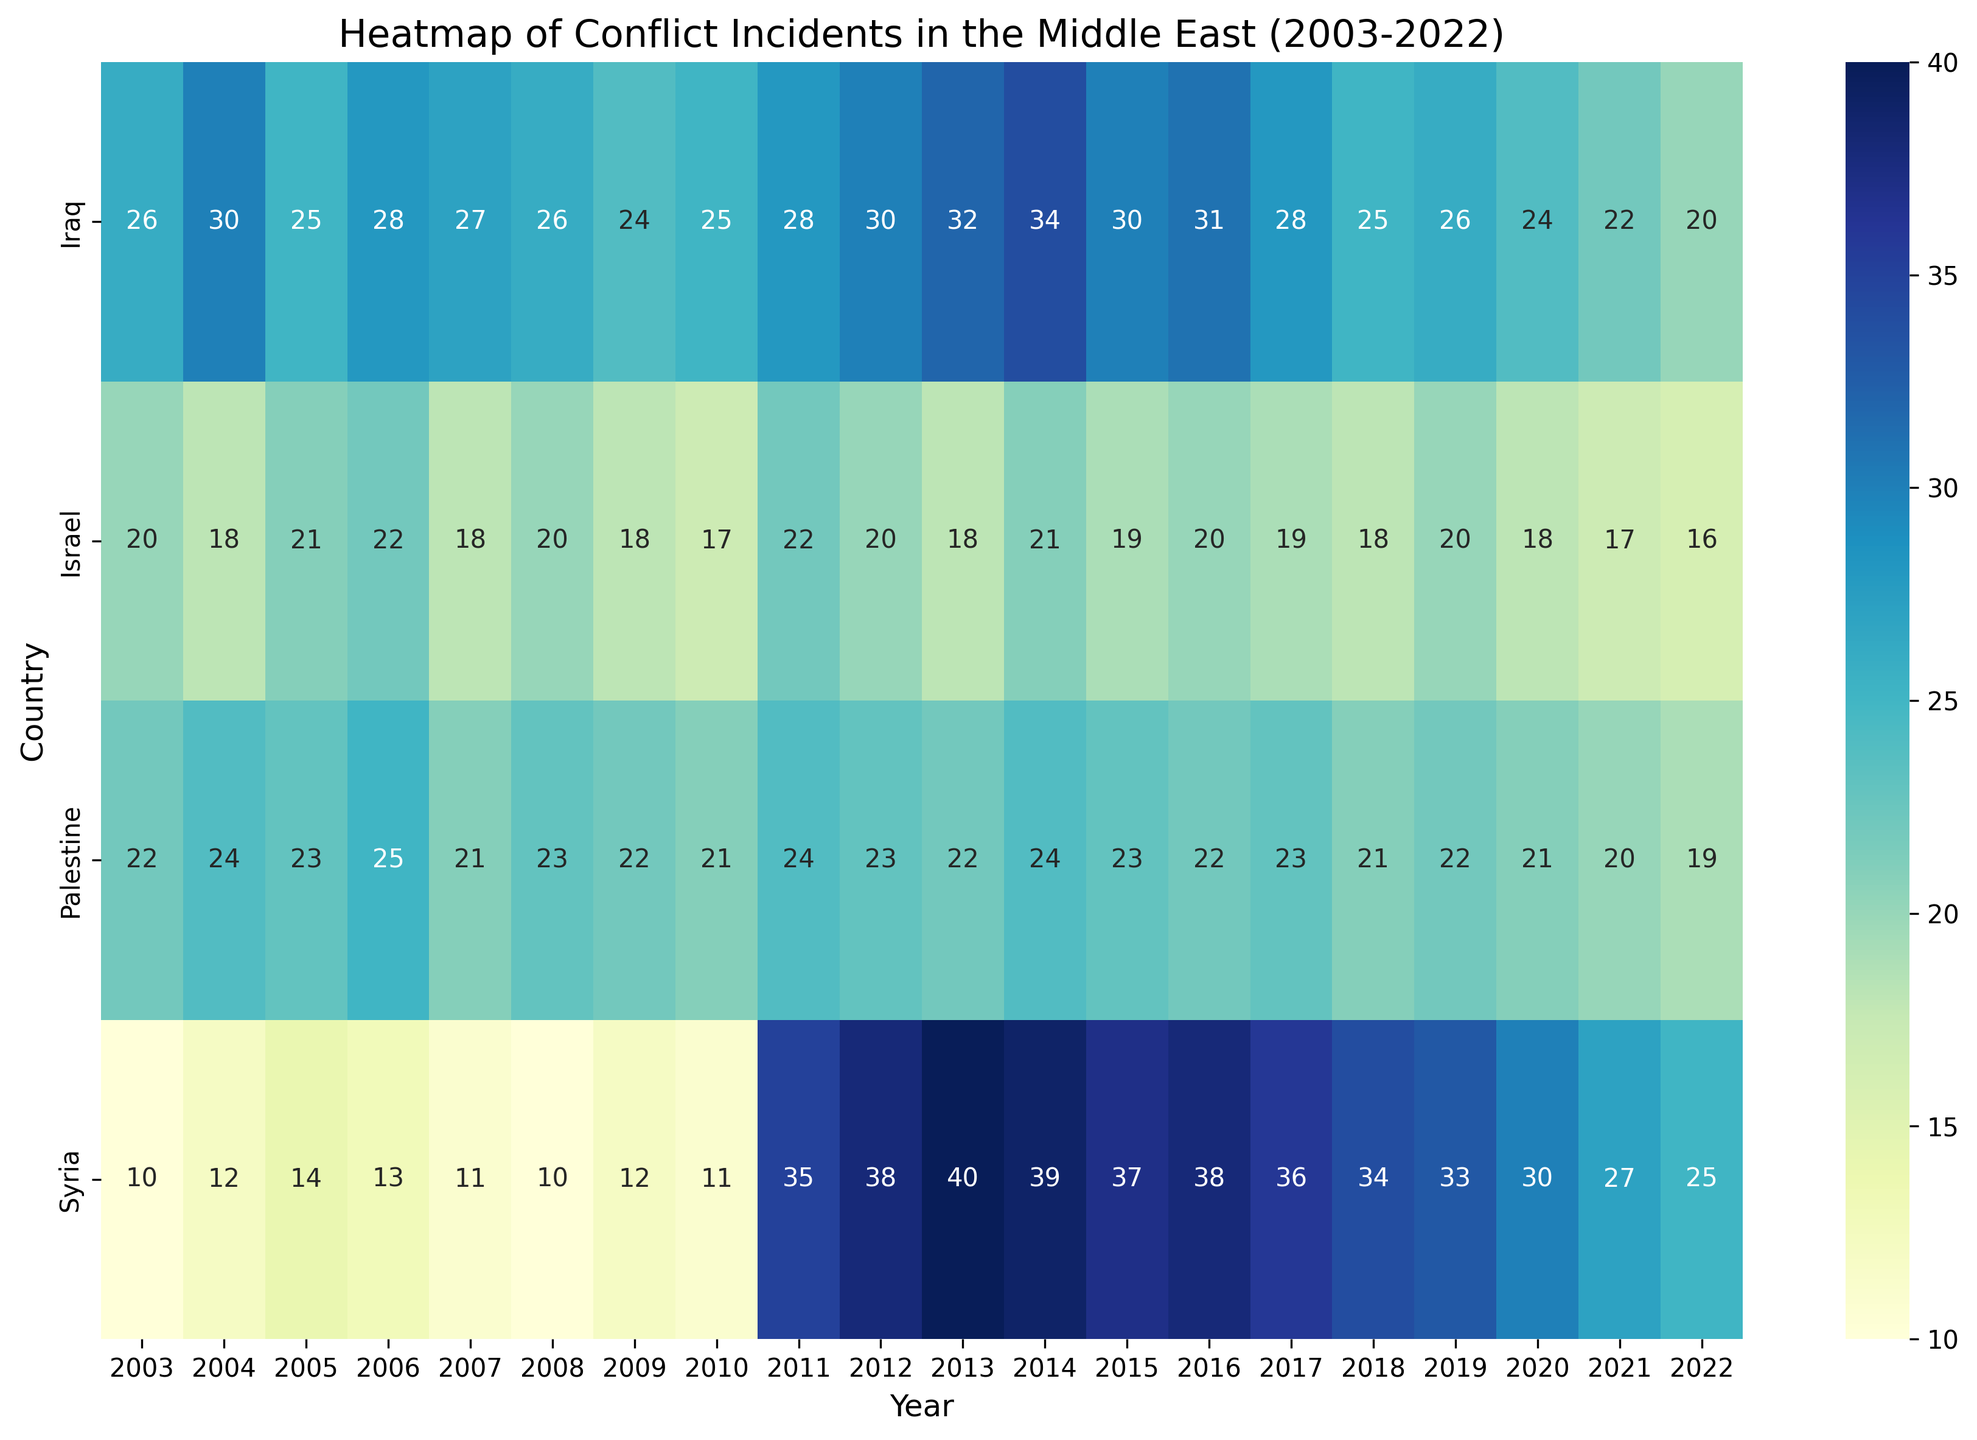Which country had the highest number of conflict incidents in 2011? Looking at the heatmap, the country with the darkest shade in 2011 represents the highest number of conflict incidents. Syria has the darkest shade for this year.
Answer: Syria Which country showed a significant increase in peace initiatives from 2018 to 2022? To determine this, compare the color shades corresponding to peace initiatives between 2018 and 2022 across all countries. Syria shows a significant change in color, indicating an increase in peace initiatives.
Answer: Syria Did Israel have more conflict incidents in 2006 or in 2013? By comparing the color intensity for Israel in both years, we see that the shade for 2006 is darker than for 2013, indicating more conflict incidents in 2006.
Answer: 2006 Which year had the highest number of conflict incidents for Iraq? Identify the darkest shade across the years for Iraq. The darkest shade appears in 2004.
Answer: 2004 Did conflict incidents in Syria generally increase or decrease over the years from 2003 to 2022? Observing the color gradient for Syria from 2003 to 2022, it shows a trend from lighter to darker shades, indicating an increase in conflict incidents over the years.
Answer: Increase How does the average number of conflict incidents in Palestine from 2003 to 2007 compare to that from 2018 to 2022? Calculate the average for each period: (22+24+23+25+21) / 5 = 23 for 2003-2007, and (21+22+23+21+19) / 5 = 21.2 for 2018-2022. The average was higher from 2003 to 2007.
Answer: Higher in 2003-2007 Which year had the fewest conflict incidents in Israel? Find the year with the lightest shade for Israel, which represents the fewest conflict incidents. The year is 2022.
Answer: 2022 Compare the number of conflict incidents in Iraq and Palestine in 2010. Which country had more, and by how much? The heatmap shows 25 incidents for Iraq and 21 for Palestine in 2010. Iraq had 4 more conflict incidents than Palestine in 2010.
Answer: Iraq by 4 In which year did Syria have the largest number of peace initiatives? Observe the color shade representing peace initiatives for Syria across all years. The darkest shade is in 2022.
Answer: 2022 Between 2017 and 2021, which country experienced a decrease in the number of conflict incidents? Compare the shades for each country between 2017 and 2021. Iraq and Israel show a noticeable decrease in the intensity of the color representing conflict incidents.
Answer: Iraq and Israel 